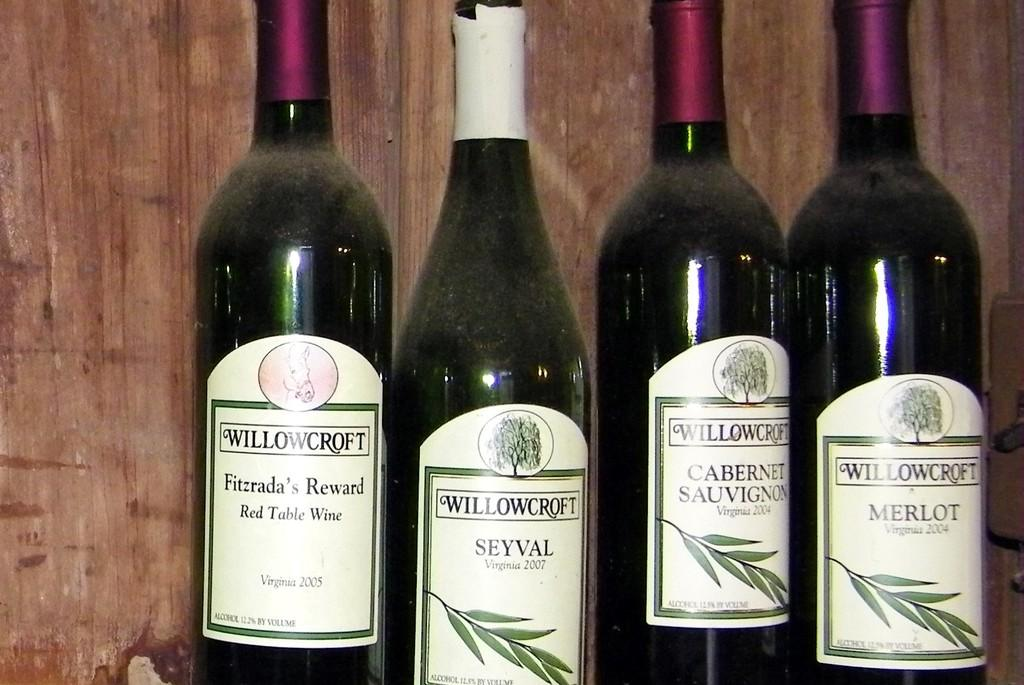<image>
Describe the image concisely. Several bottles of Willowcroft wine are lined up in front of a wooden wall. 